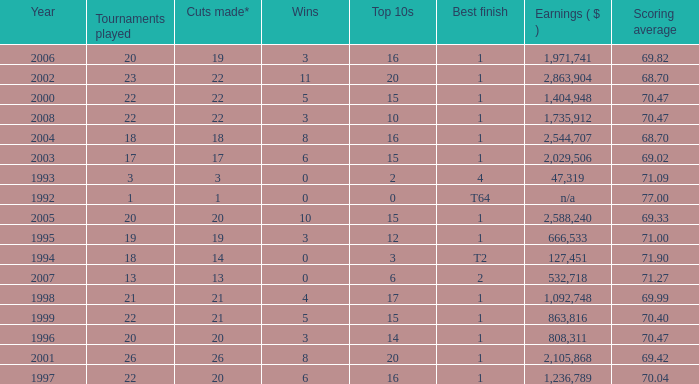Tell me the highest wins for year less than 2000 and best finish of 4 and tournaments played less than 3 None. 